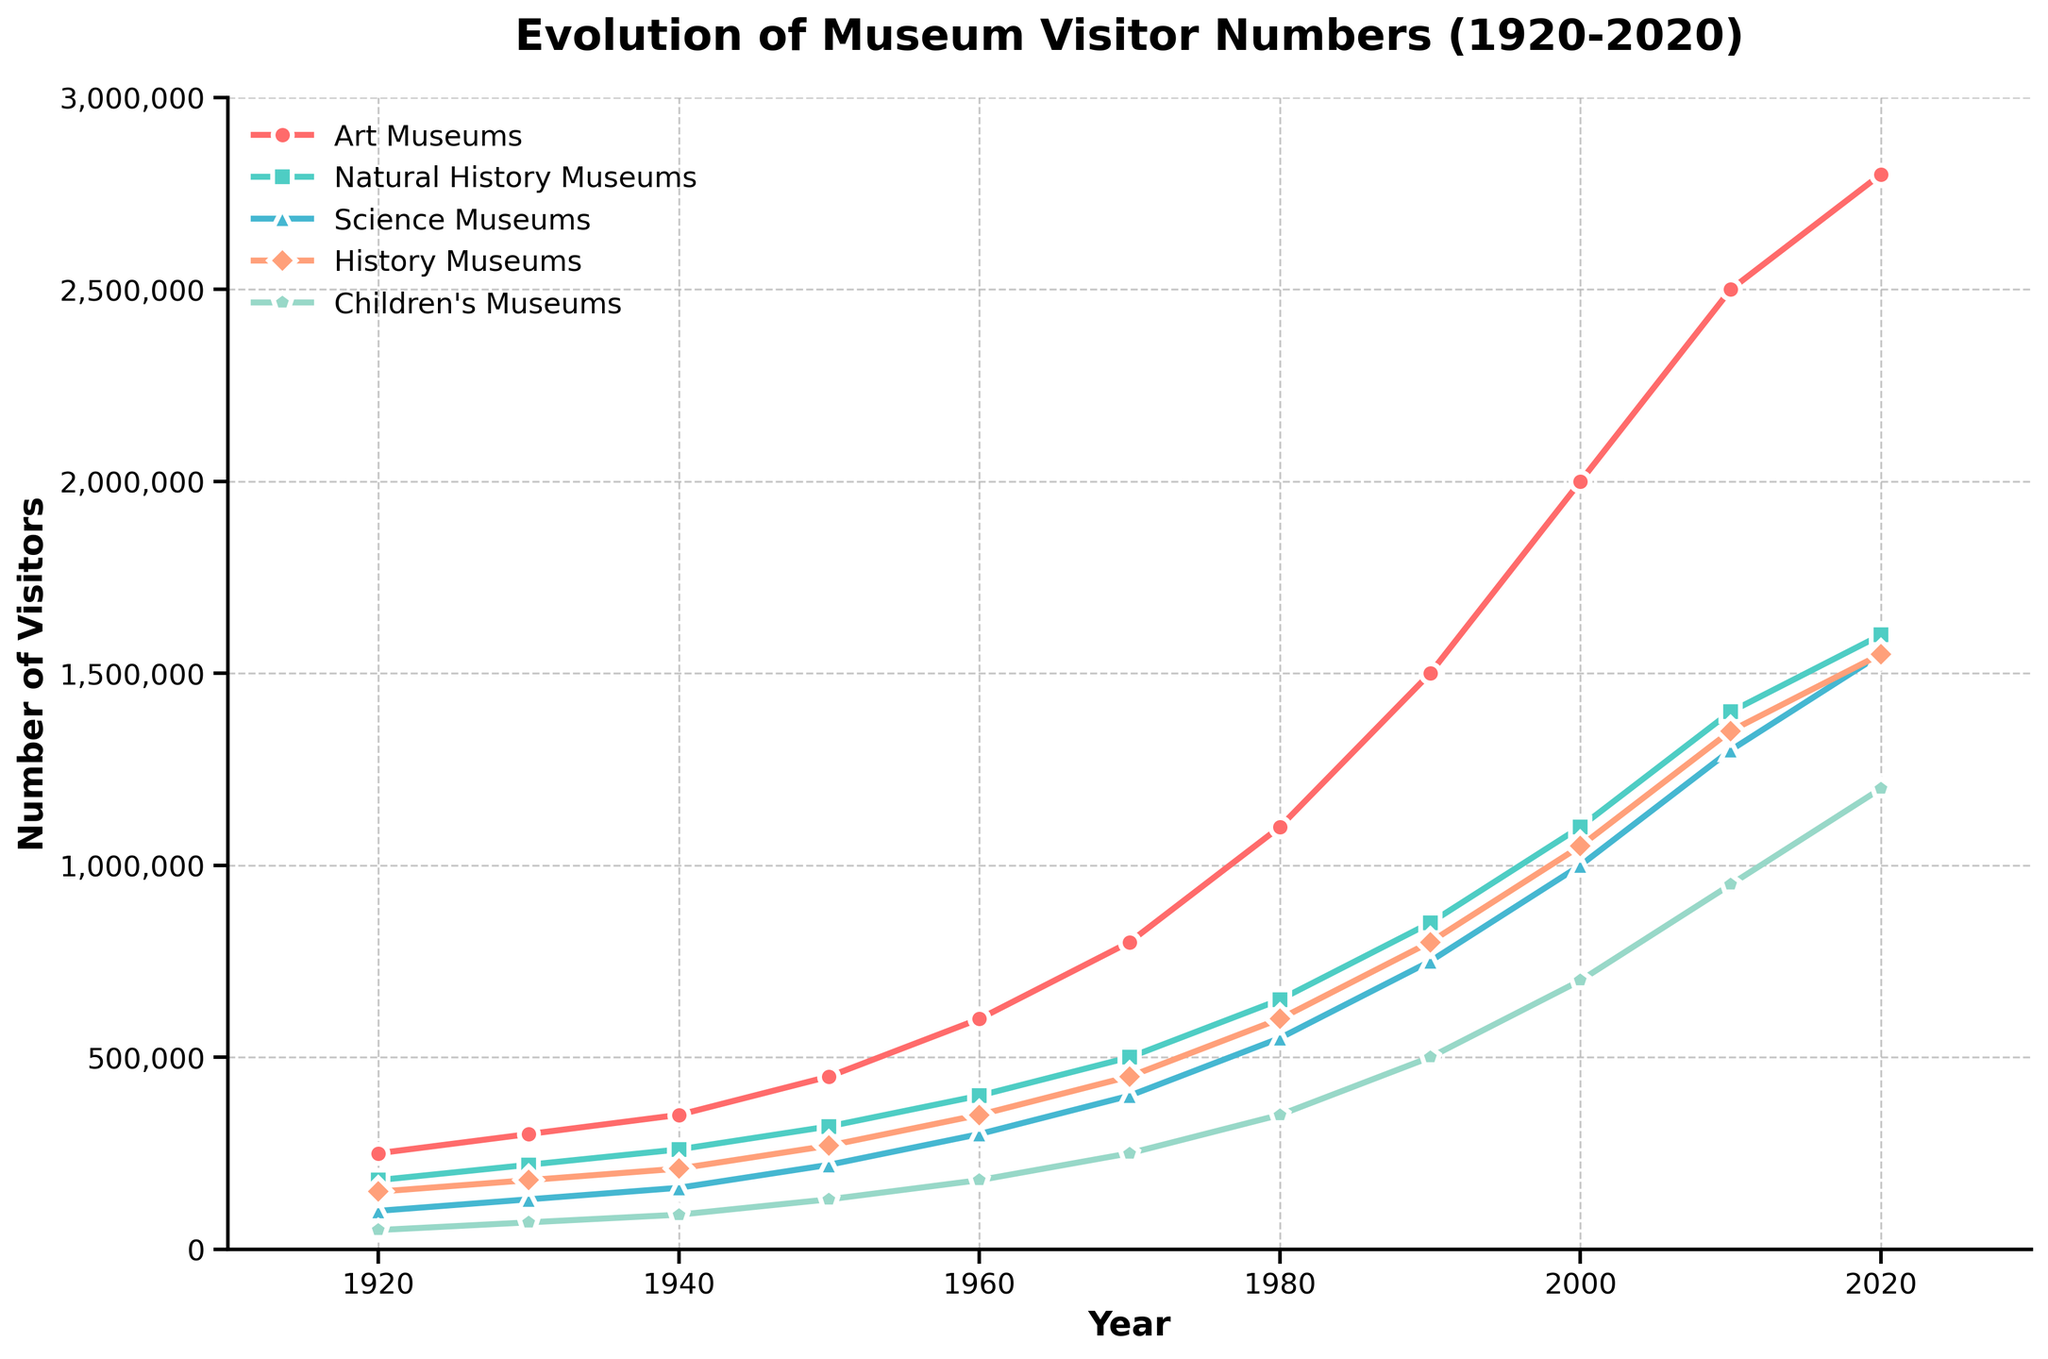What's the total number of visitors for all museums in 1920? To get the total, sum all the visitor numbers for each type of museum in 1920: 250,000 (Art) + 180,000 (Natural History) + 100,000 (Science) + 150,000 (History) + 50,000 (Children’s) = 730,000
Answer: 730,000 Which type of museum had the highest number of visitors in 2020, and what was the number? By looking at the endpoints for each line on the graph for 2020, the type with the highest number is the Art Museums with 2,800,000 visitors.
Answer: Art Museums, 2,800,000 How did the number of visitors to Science Museums change between 1940 and 1970? To find the change, subtract the number of visitors in 1940 from the number in 1970: 400,000 (1970) - 160,000 (1940) = 240,000.
Answer: Increased by 240,000 Which museum type saw the smallest increase in visitors from 2010 to 2020? Check the increase in visitor numbers for each type by subtracting 2010 numbers from 2020 numbers: Art (300,000), Natural History (200,000), Science (250,000), History (200,000), Children’s (250,000). So, Natural History and History Museums saw the smallest increase, which is 200,000.
Answer: Natural History Museums and History Museums, 200,000 Between 1950 and 1960, which museum type saw the highest percentage increase in visitors? Calculate the percentage increase for each museum type: (1) Art: (600,000-450,000)/450,000 * 100 = 33.3%, (2) Natural History: (400,000-320,000)/320,000 * 100 = 25%, (3) Science: (300,000-220,000)/220,000 * 100 = 36.4%, (4) History: (350,000-270,000)/270,000 * 100 = 29.6%, (5) Children’s: (180,000-130,000)/130,000 * 100 = 38.5%. Therefore, Children's Museums had the highest percentage increase.
Answer: Children's Museums, 38.5% What was the difference in visitor numbers between Art Museums and Children's Museums in 2000? Subtract the number of visitors of Children's Museums from Art Museums in 2000: 2,000,000 (Art) - 700,000 (Children’s) = 1,300,000
Answer: 1,300,000 Which museum type had the most visitors in 1950, and how many did it have? By looking at the visual peaks in 1950, Art Museums had the most visitors with 450,000 visitors.
Answer: Art Museums, 450,000 How many more visitors did Science Museums have in 2010 compared to 1930? Subtract the number of Science Museum visitors in 1930 from the number in 2010: 1,300,000 (2010) - 130,000 (1930) = 1,170,000
Answer: 1,170,000 